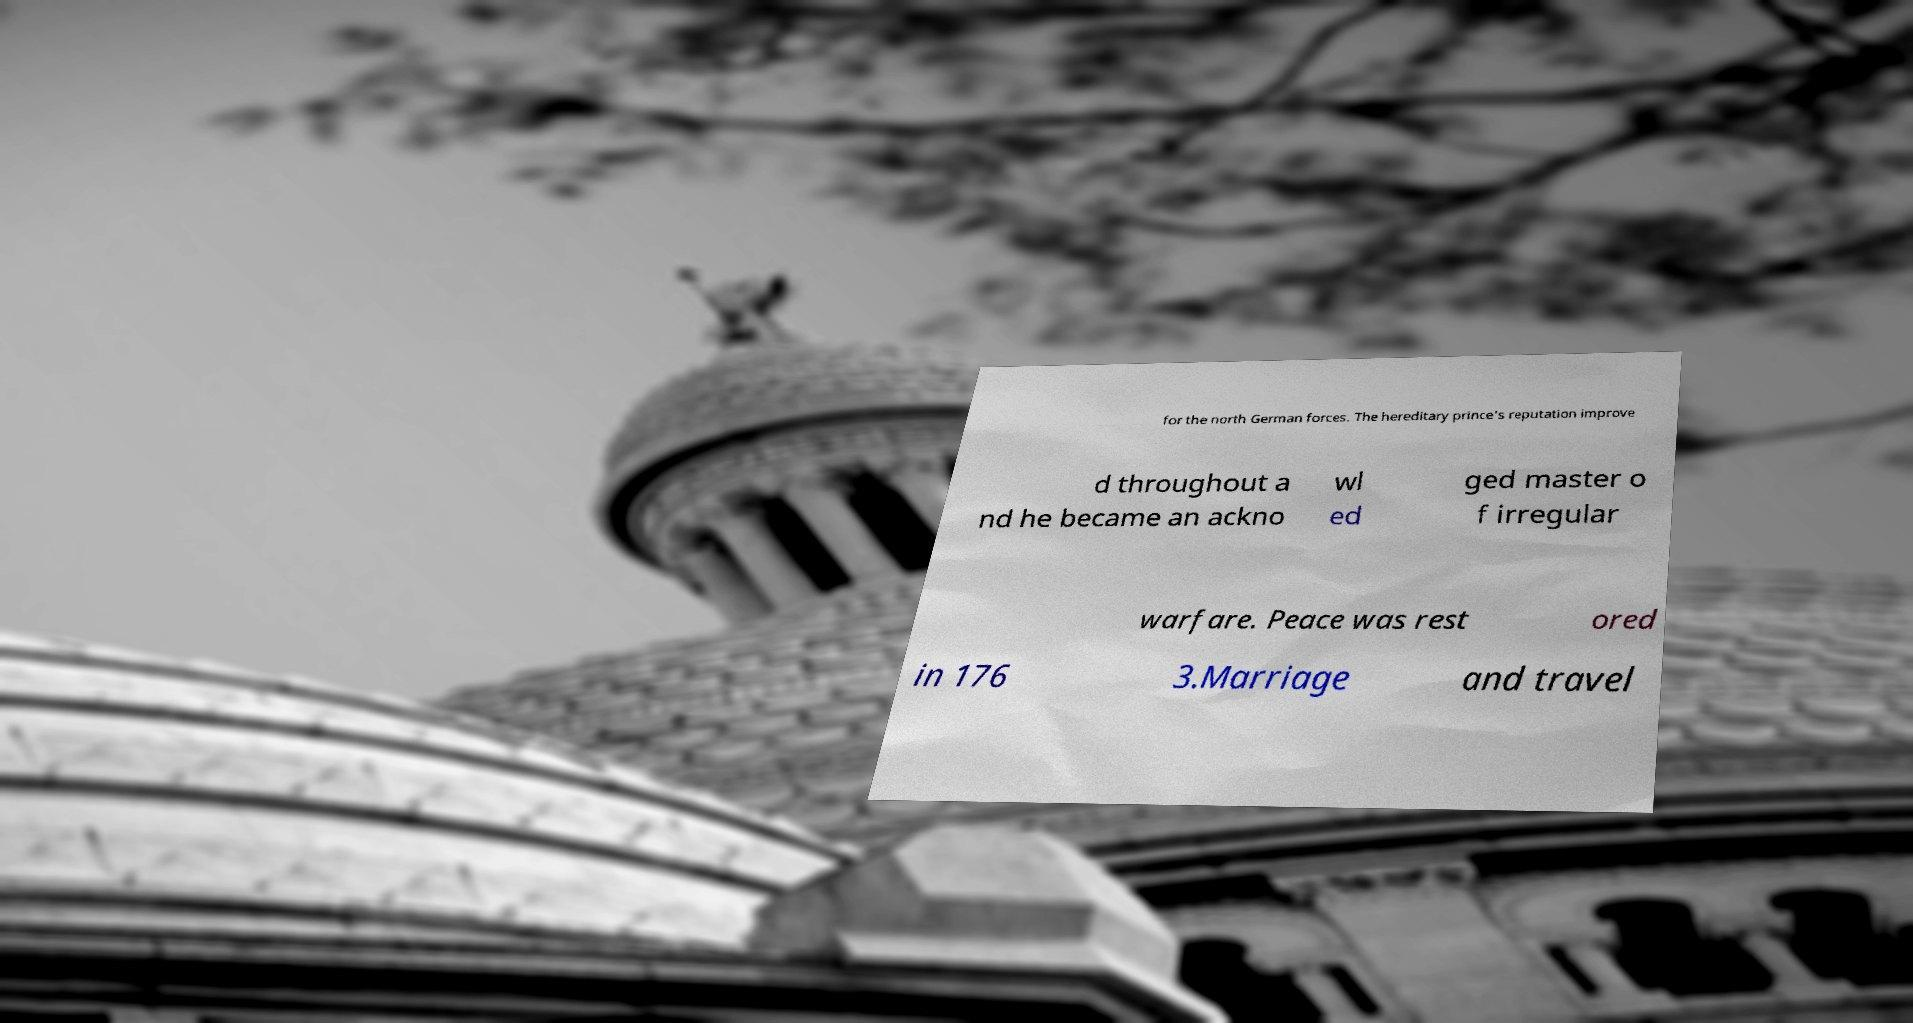Could you extract and type out the text from this image? for the north German forces. The hereditary prince's reputation improve d throughout a nd he became an ackno wl ed ged master o f irregular warfare. Peace was rest ored in 176 3.Marriage and travel 